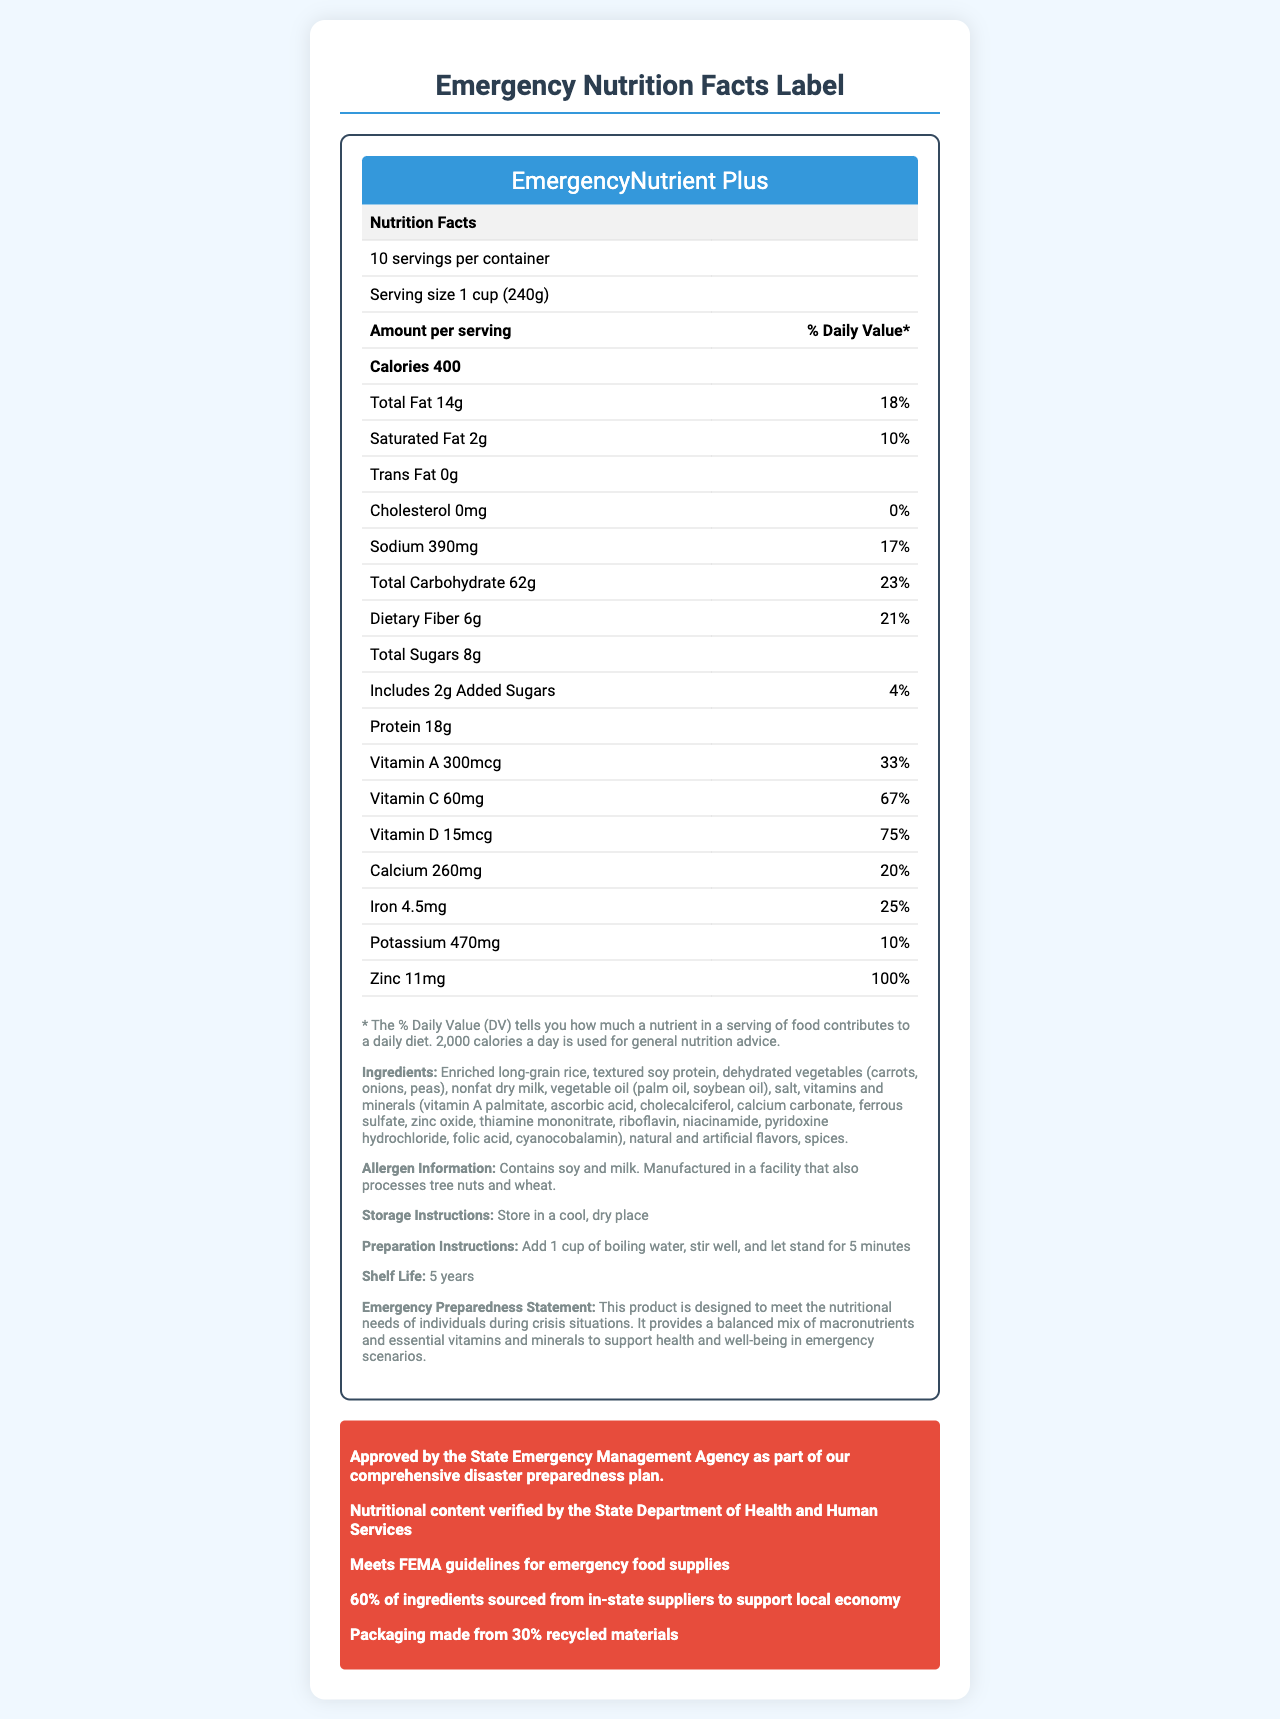what is the product name? The product name is clearly stated at the top of the Nutrition Facts Label.
Answer: EmergencyNutrient Plus how many servings are in each container? The label states "10 servings per container" directly below the nutrition header.
Answer: 10 how many calories are in one serving? The label specifies "Calories 400" under the section "Amount per serving."
Answer: 400 what is the daily value percentage of Vitamin D per serving? The daily value percentage for Vitamin D is listed as 75% next to the amount of 15mcg.
Answer: 75% what are the main ingredients of the product? The ingredients are listed in the footer section of the nutrition label.
Answer: Enriched long-grain rice, textured soy protein, dehydrated vegetables (carrots, onions, peas), nonfat dry milk, vegetable oil (palm oil, soybean oil), salt, vitamins and minerals, natural and artificial flavors, spices which vitamin has the highest daily value percentage? A. Vitamin A, B. Vitamin C, C. Vitamin D, D. Vitamin B12 Vitamin D has a daily value of 75%, which is higher than that of other vitamins listed.
Answer: C. Vitamin D how long is the shelf life of the product? A. 3 years, B. 4 years, C. 5 years, D. 6 years The shelf life is mentioned as "5 years" in the footer section under "Shelf Life."
Answer: C. 5 years is the product free from tree nuts and wheat? The allergen information states that the product is manufactured in a facility that also processes tree nuts and wheat.
Answer: No does this product meet federal guidelines? The governor's note mentions that the product meets FEMA guidelines for emergency food supplies.
Answer: Yes summarize the purpose and features of the EmergencyNutrient Plus. The document describes the EmergencyNutrient Plus as an emergency food supply product that meets federal guidelines and offers balanced nutrition, with details on its nutritional content, ingredients, and compliance with state and federal standards.
Answer: The EmergencyNutrient Plus is designed to provide balanced nutrition during crisis situations. It offers 400 calories per serving with essential macronutrients, vitamins, and minerals. The product has a 5-year shelf life and is verified by the State Department of Health and Human Services. It is also sourced partially from local suppliers and packaged with sustainability in mind. which emergency agency approved this product as part of the disaster preparedness plan? The governor's note includes a statement of approval from the State Emergency Management Agency.
Answer: State Emergency Management Agency how much protein does one serving of the product provide? The amount of protein per serving is listed as 18g in the nutrition facts table.
Answer: 18g can we determine the exact percentage of recycled materials used in the packaging? The sustainability note mentions that the packaging is made from 30% recycled materials.
Answer: Yes what information is available about the sodium content? The sodium content is listed as 390mg per serving with a daily value percentage of 17%.
Answer: 390mg, 17% daily value how many added sugars are in one serving? The added sugars amount and daily value percentage are listed as 2g and 4% respectively in the nutrition facts.
Answer: 2g, 4% daily value what is the preparation instruction for the product? The preparation instruction is provided in the footer section of the nutrition label.
Answer: Add 1 cup of boiling water, stir well, and let stand for 5 minutes what is the main idea of the emergency preparedness statement? The emergency preparedness statement emphasizes that the product's purpose is to meet nutritional needs during crisis situations with a balanced mix of essential nutrients.
Answer: The product is designed to support health and well-being during emergencies by providing balanced nutrition. what percentage of ingredients are sourced from out-of-state suppliers? The document only states that 60% of the ingredients are sourced from in-state suppliers; it does not provide information about the percentage of ingredients sourced from out-of-state suppliers.
Answer: Cannot be determined 